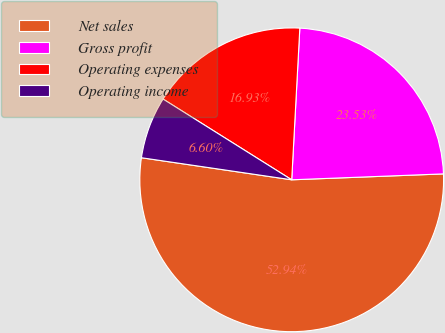Convert chart to OTSL. <chart><loc_0><loc_0><loc_500><loc_500><pie_chart><fcel>Net sales<fcel>Gross profit<fcel>Operating expenses<fcel>Operating income<nl><fcel>52.94%<fcel>23.53%<fcel>16.93%<fcel>6.6%<nl></chart> 